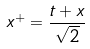Convert formula to latex. <formula><loc_0><loc_0><loc_500><loc_500>x ^ { + } = \frac { t + x } { \sqrt { 2 } }</formula> 